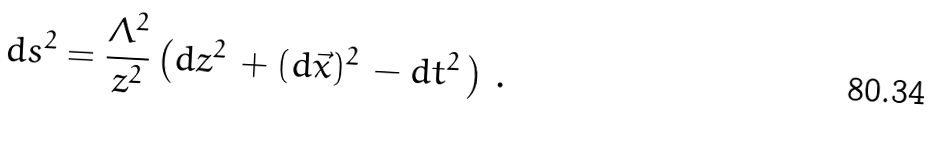Convert formula to latex. <formula><loc_0><loc_0><loc_500><loc_500>d s ^ { 2 } = \frac { \Lambda ^ { 2 } } { z ^ { 2 } } \left ( d z ^ { 2 } \, + ( d \vec { x } ) ^ { 2 } \, - d t ^ { 2 } \, \right ) \, .</formula> 